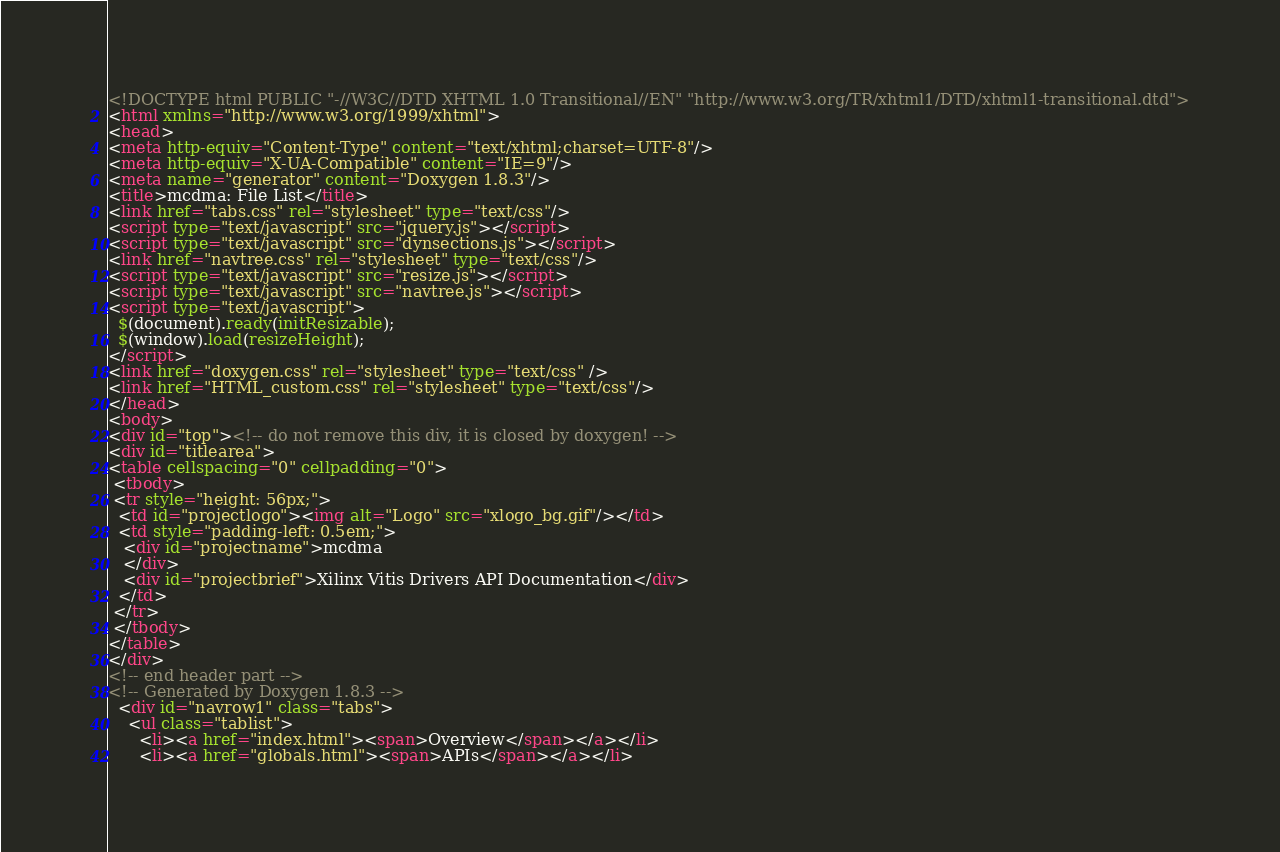Convert code to text. <code><loc_0><loc_0><loc_500><loc_500><_HTML_><!DOCTYPE html PUBLIC "-//W3C//DTD XHTML 1.0 Transitional//EN" "http://www.w3.org/TR/xhtml1/DTD/xhtml1-transitional.dtd">
<html xmlns="http://www.w3.org/1999/xhtml">
<head>
<meta http-equiv="Content-Type" content="text/xhtml;charset=UTF-8"/>
<meta http-equiv="X-UA-Compatible" content="IE=9"/>
<meta name="generator" content="Doxygen 1.8.3"/>
<title>mcdma: File List</title>
<link href="tabs.css" rel="stylesheet" type="text/css"/>
<script type="text/javascript" src="jquery.js"></script>
<script type="text/javascript" src="dynsections.js"></script>
<link href="navtree.css" rel="stylesheet" type="text/css"/>
<script type="text/javascript" src="resize.js"></script>
<script type="text/javascript" src="navtree.js"></script>
<script type="text/javascript">
  $(document).ready(initResizable);
  $(window).load(resizeHeight);
</script>
<link href="doxygen.css" rel="stylesheet" type="text/css" />
<link href="HTML_custom.css" rel="stylesheet" type="text/css"/>
</head>
<body>
<div id="top"><!-- do not remove this div, it is closed by doxygen! -->
<div id="titlearea">
<table cellspacing="0" cellpadding="0">
 <tbody>
 <tr style="height: 56px;">
  <td id="projectlogo"><img alt="Logo" src="xlogo_bg.gif"/></td>
  <td style="padding-left: 0.5em;">
   <div id="projectname">mcdma
   </div>
   <div id="projectbrief">Xilinx Vitis Drivers API Documentation</div>
  </td>
 </tr>
 </tbody>
</table>
</div>
<!-- end header part -->
<!-- Generated by Doxygen 1.8.3 -->
  <div id="navrow1" class="tabs">
    <ul class="tablist">
      <li><a href="index.html"><span>Overview</span></a></li>
      <li><a href="globals.html"><span>APIs</span></a></li></code> 